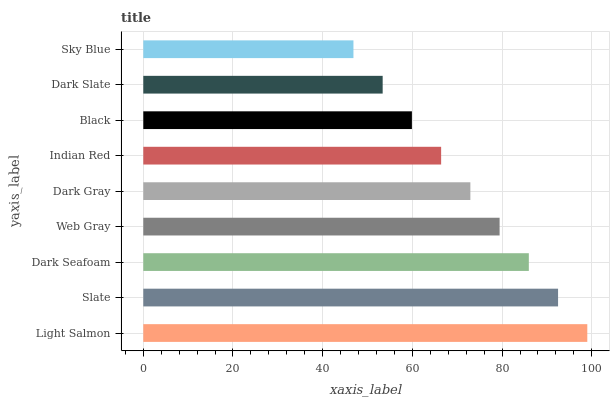Is Sky Blue the minimum?
Answer yes or no. Yes. Is Light Salmon the maximum?
Answer yes or no. Yes. Is Slate the minimum?
Answer yes or no. No. Is Slate the maximum?
Answer yes or no. No. Is Light Salmon greater than Slate?
Answer yes or no. Yes. Is Slate less than Light Salmon?
Answer yes or no. Yes. Is Slate greater than Light Salmon?
Answer yes or no. No. Is Light Salmon less than Slate?
Answer yes or no. No. Is Dark Gray the high median?
Answer yes or no. Yes. Is Dark Gray the low median?
Answer yes or no. Yes. Is Indian Red the high median?
Answer yes or no. No. Is Dark Slate the low median?
Answer yes or no. No. 